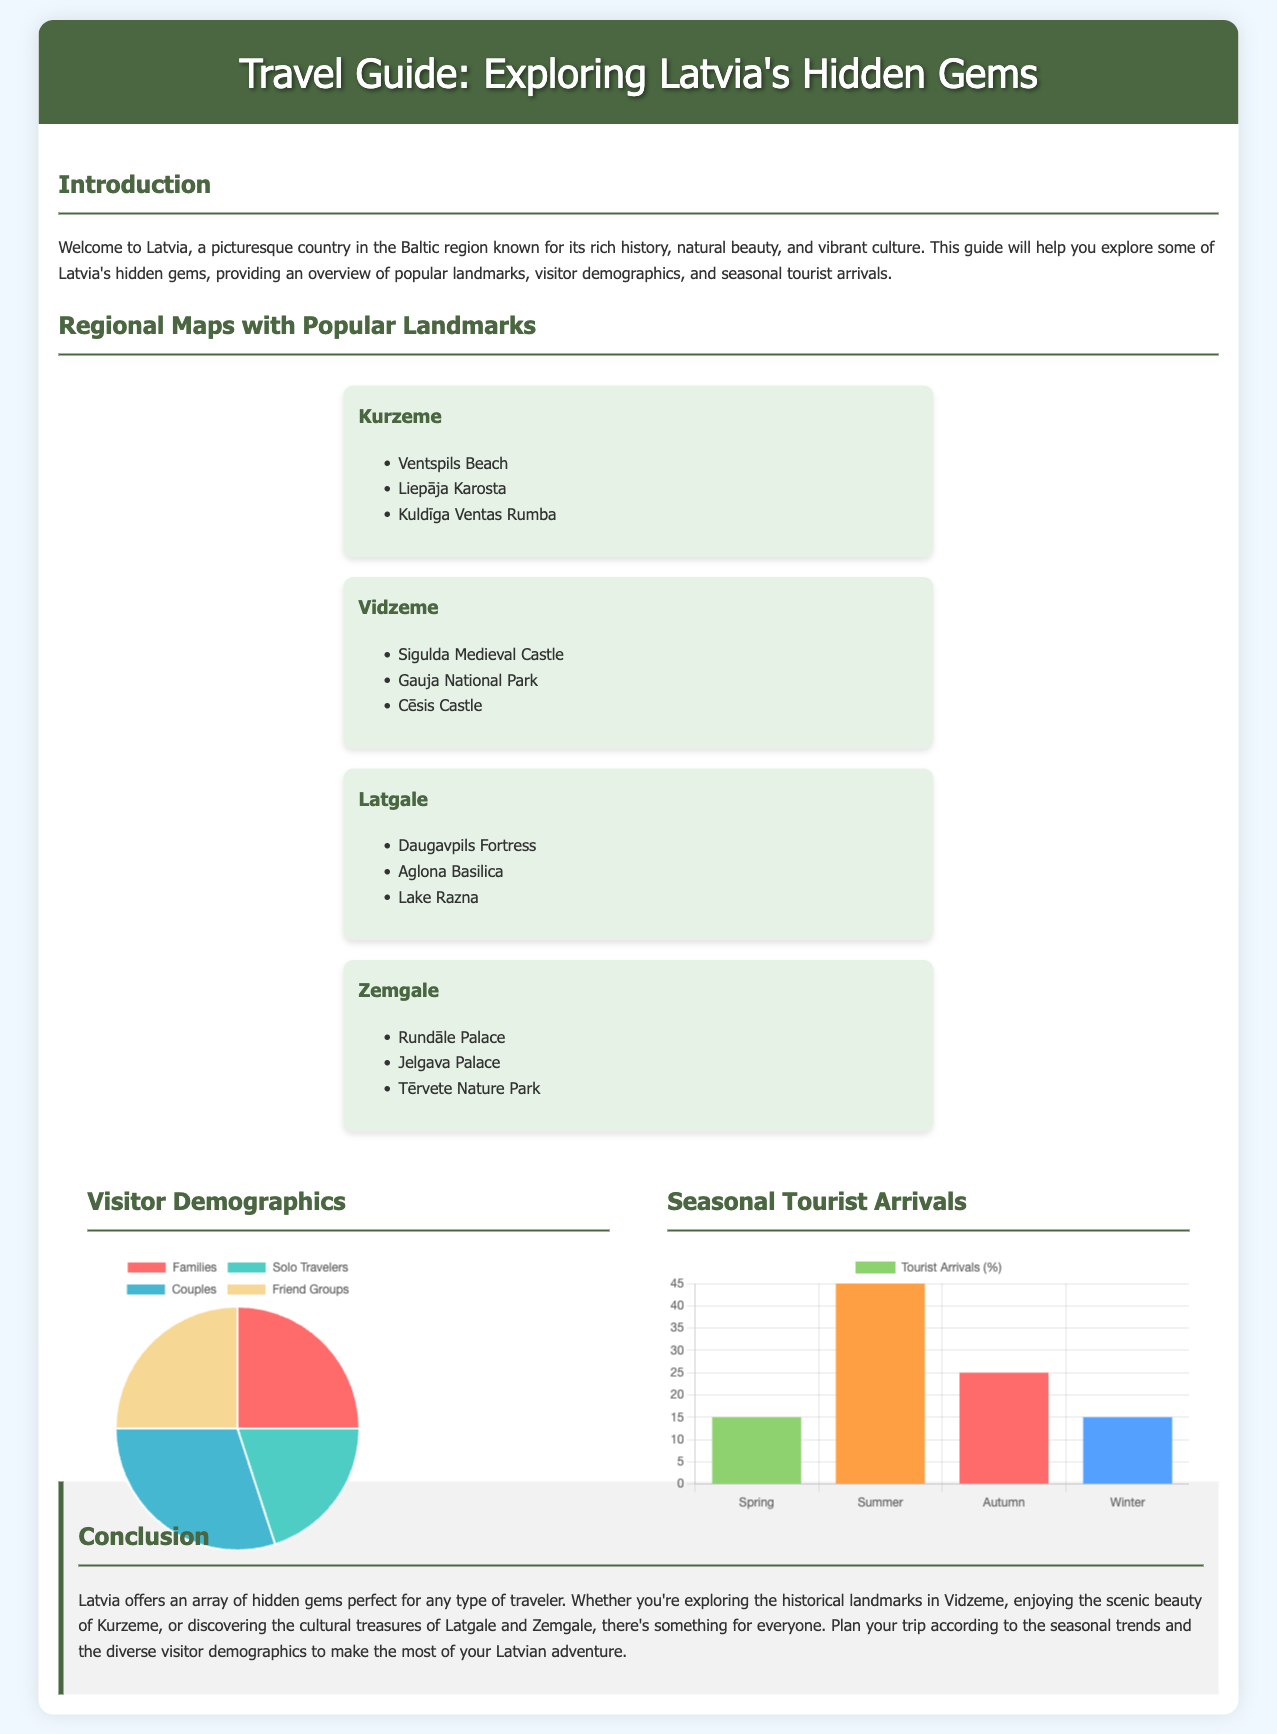What are the three popular landmarks in Kurzeme? The document lists Ventspils Beach, Liepāja Karosta, and Kuldīga Ventas Rumba as popular landmarks in the Kurzeme region.
Answer: Ventspils Beach, Liepāja Karosta, Kuldīga Ventas Rumba What is the percentage of solo travelers visiting Latvia? According to the visitor demographics pie chart, solo travelers make up 20% of the total visitor demographics.
Answer: 20% Which region has the landmark Sigulda Medieval Castle? The document states that Sigulda Medieval Castle is located in the Vidzeme region.
Answer: Vidzeme What is the total percentage of tourists arriving in summer? The seasonal tourist arrivals bar chart shows that summer has 45% of the tourist arrivals.
Answer: 45% What is the least visited season according to the seasonal arrivals chart? The bar chart indicates that winter has the least percentage of tourist arrivals at 15%.
Answer: Winter How many different visitor demographic groups are shown in the pie chart? The visitor demographics chart displays four groups: Families, Solo Travelers, Couples, and Friend Groups.
Answer: Four Which region features Aglona Basilica? Aglona Basilica is a landmark found in the Latgale region as per the document.
Answer: Latgale What color represents friend groups in the demographics pie chart? In the pie chart, friend groups are represented by the color yellow (#f7d794).
Answer: Yellow What landmark is mentioned in the Zemgale region? The document lists Rundāle Palace as a popular landmark in the Zemgale region.
Answer: Rundāle Palace 